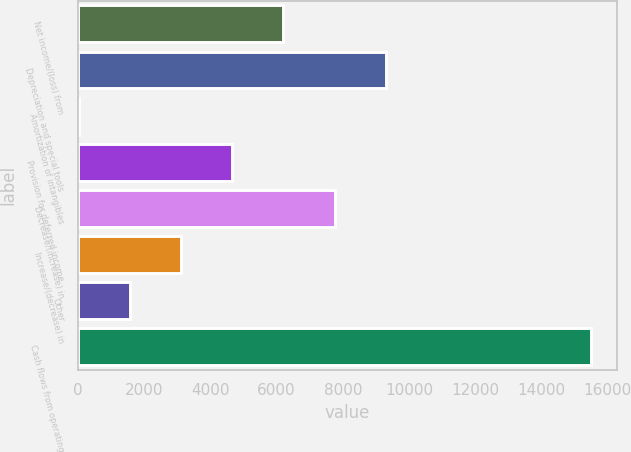<chart> <loc_0><loc_0><loc_500><loc_500><bar_chart><fcel>Net income/(loss) from<fcel>Depreciation and special tools<fcel>Amortization of intangibles<fcel>Provision for deferred income<fcel>Decrease/(increase) in<fcel>Increase/(decrease) in<fcel>Other<fcel>Cash flows from operating<nl><fcel>6206.4<fcel>9304.6<fcel>10<fcel>4657.3<fcel>7755.5<fcel>3108.2<fcel>1559.1<fcel>15501<nl></chart> 